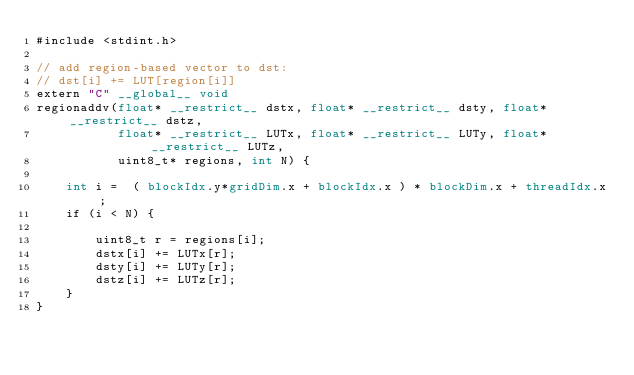Convert code to text. <code><loc_0><loc_0><loc_500><loc_500><_Cuda_>#include <stdint.h>

// add region-based vector to dst:
// dst[i] += LUT[region[i]]
extern "C" __global__ void
regionaddv(float* __restrict__ dstx, float* __restrict__ dsty, float* __restrict__ dstz,
           float* __restrict__ LUTx, float* __restrict__ LUTy, float* __restrict__ LUTz,
           uint8_t* regions, int N) {

    int i =  ( blockIdx.y*gridDim.x + blockIdx.x ) * blockDim.x + threadIdx.x;
    if (i < N) {

        uint8_t r = regions[i];
        dstx[i] += LUTx[r];
        dsty[i] += LUTy[r];
        dstz[i] += LUTz[r];
    }
}

</code> 